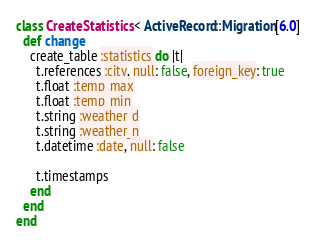<code> <loc_0><loc_0><loc_500><loc_500><_Ruby_>class CreateStatistics < ActiveRecord::Migration[6.0]
  def change
    create_table :statistics do |t|
      t.references :city, null: false, foreign_key: true
      t.float :temp_max
      t.float :temp_min
      t.string :weather_d
      t.string :weather_n
      t.datetime :date, null: false

      t.timestamps
    end
  end
end
</code> 